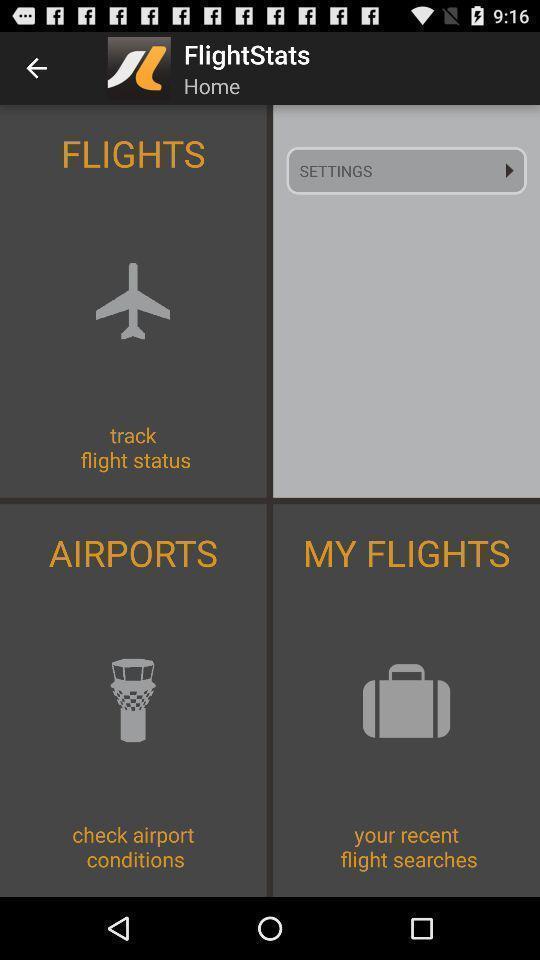What is the overall content of this screenshot? Page showing the flight stats. 